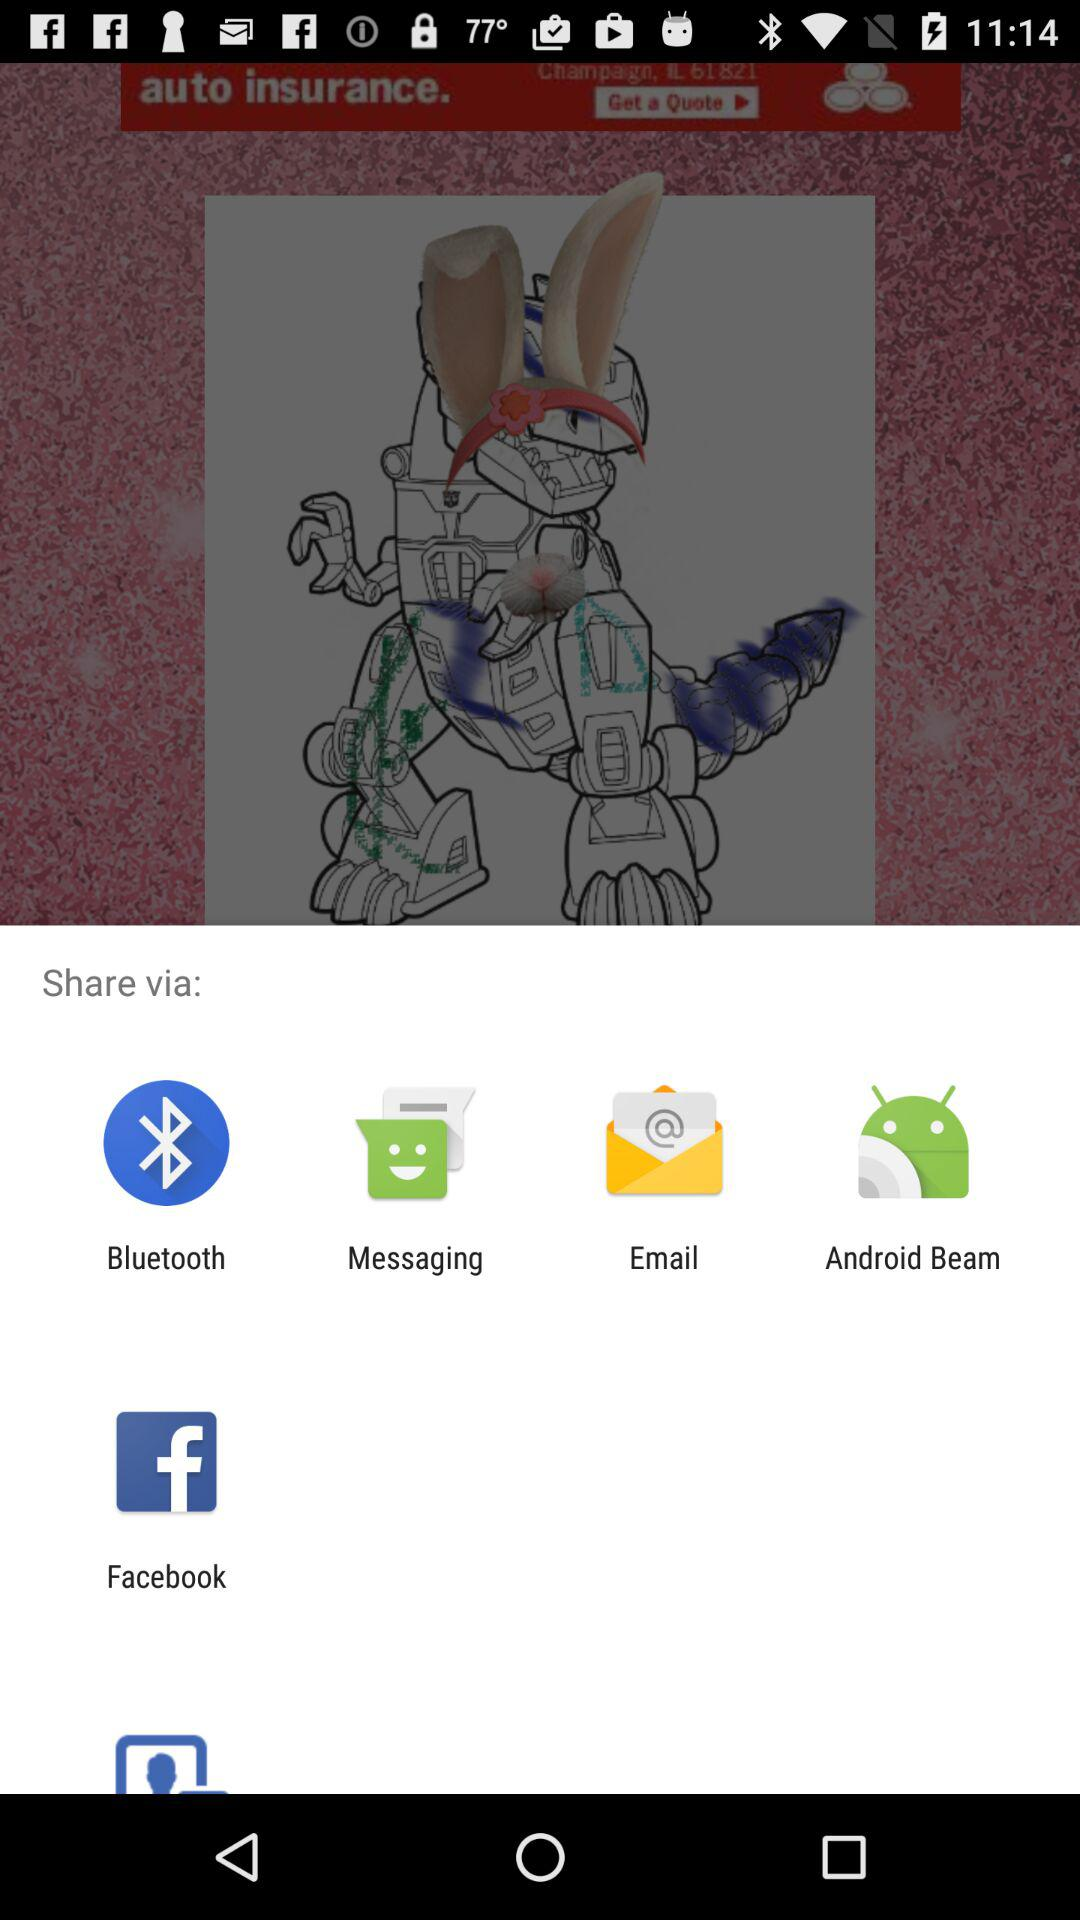How many images are there in total?
When the provided information is insufficient, respond with <no answer>. <no answer> 